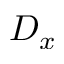<formula> <loc_0><loc_0><loc_500><loc_500>D _ { x }</formula> 